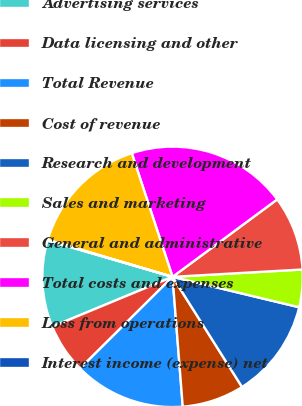Convert chart. <chart><loc_0><loc_0><loc_500><loc_500><pie_chart><fcel>Advertising services<fcel>Data licensing and other<fcel>Total Revenue<fcel>Cost of revenue<fcel>Research and development<fcel>Sales and marketing<fcel>General and administrative<fcel>Total costs and expenses<fcel>Loss from operations<fcel>Interest income (expense) net<nl><fcel>10.76%<fcel>6.18%<fcel>13.82%<fcel>7.71%<fcel>12.29%<fcel>4.65%<fcel>9.24%<fcel>19.93%<fcel>15.35%<fcel>0.07%<nl></chart> 